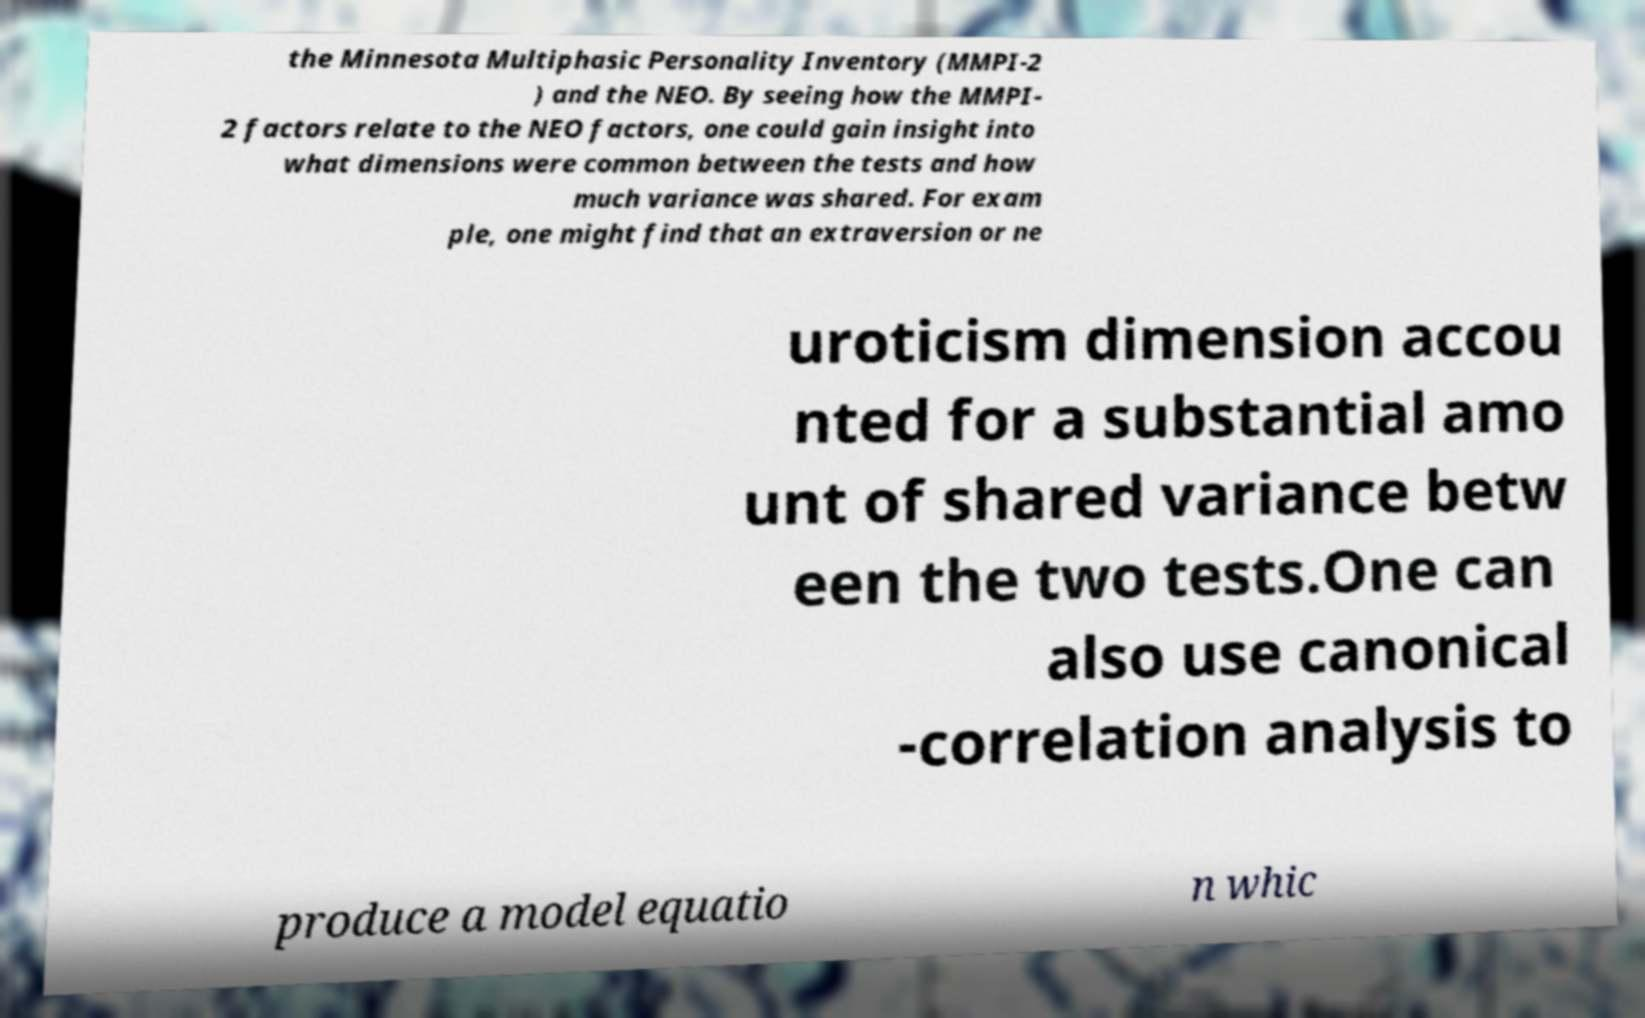Could you assist in decoding the text presented in this image and type it out clearly? the Minnesota Multiphasic Personality Inventory (MMPI-2 ) and the NEO. By seeing how the MMPI- 2 factors relate to the NEO factors, one could gain insight into what dimensions were common between the tests and how much variance was shared. For exam ple, one might find that an extraversion or ne uroticism dimension accou nted for a substantial amo unt of shared variance betw een the two tests.One can also use canonical -correlation analysis to produce a model equatio n whic 